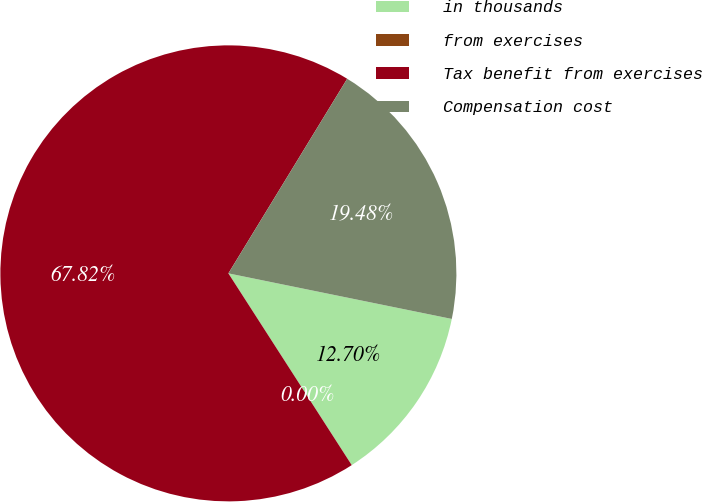<chart> <loc_0><loc_0><loc_500><loc_500><pie_chart><fcel>in thousands<fcel>from exercises<fcel>Tax benefit from exercises<fcel>Compensation cost<nl><fcel>12.7%<fcel>0.0%<fcel>67.82%<fcel>19.48%<nl></chart> 